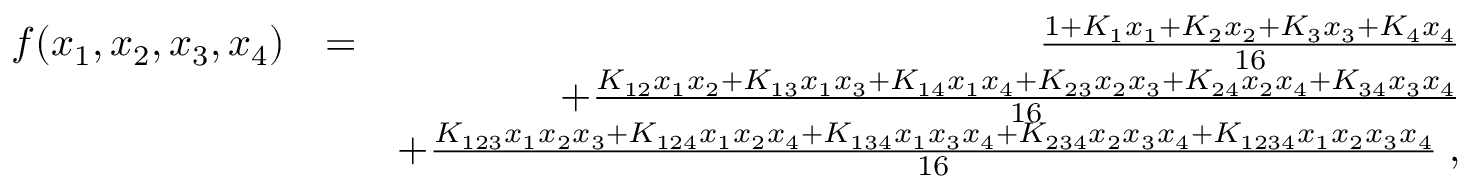<formula> <loc_0><loc_0><loc_500><loc_500>\begin{array} { r l r } { f ( x _ { 1 } , x _ { 2 } , x _ { 3 } , x _ { 4 } ) } & { = } & { \frac { 1 + K _ { 1 } x _ { 1 } + K _ { 2 } x _ { 2 } + K _ { 3 } x _ { 3 } + K _ { 4 } x _ { 4 } } { 1 6 } } \\ & { + \frac { K _ { 1 2 } x _ { 1 } x _ { 2 } + K _ { 1 3 } x _ { 1 } x _ { 3 } + K _ { 1 4 } x _ { 1 } x _ { 4 } + K _ { 2 3 } x _ { 2 } x _ { 3 } + K _ { 2 4 } x _ { 2 } x _ { 4 } + K _ { 3 4 } x _ { 3 } x _ { 4 } } { 1 6 } } \\ & { + \frac { K _ { 1 2 3 } x _ { 1 } x _ { 2 } x _ { 3 } + K _ { 1 2 4 } x _ { 1 } x _ { 2 } x _ { 4 } + K _ { 1 3 4 } x _ { 1 } x _ { 3 } x _ { 4 } + K _ { 2 3 4 } x _ { 2 } x _ { 3 } x _ { 4 } + K _ { 1 2 3 4 } x _ { 1 } x _ { 2 } x _ { 3 } x _ { 4 } } { 1 6 } \, , } \end{array}</formula> 